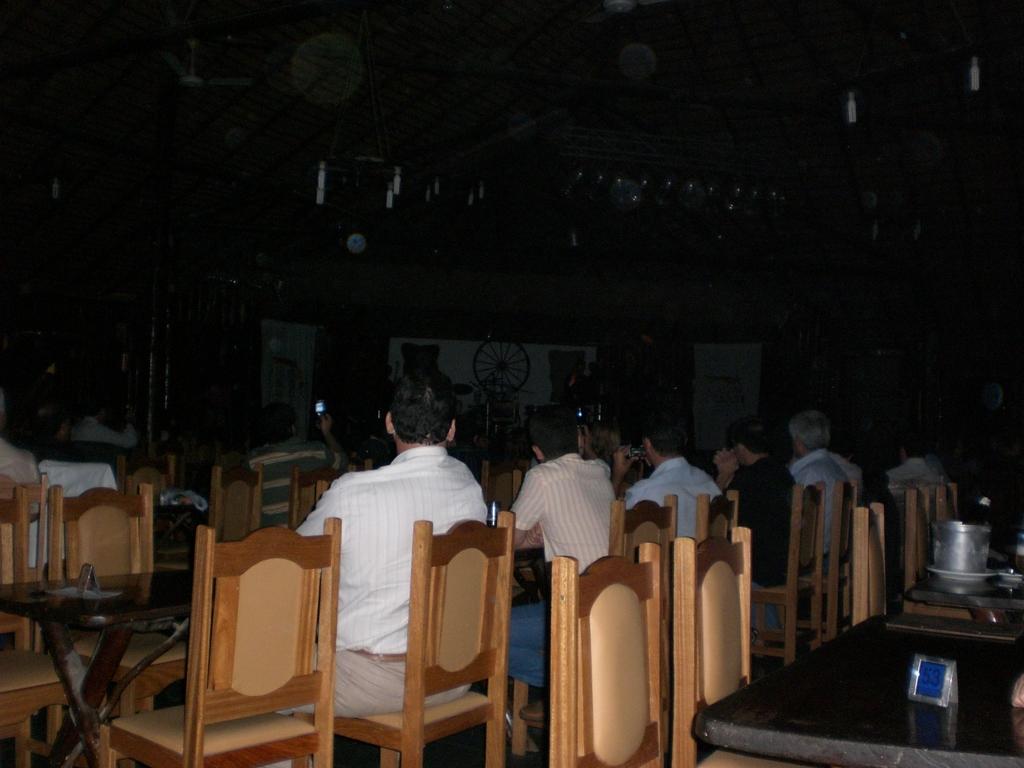How would you summarize this image in a sentence or two? This picture shows a group of people seated on the chairs and we see couple of tables 